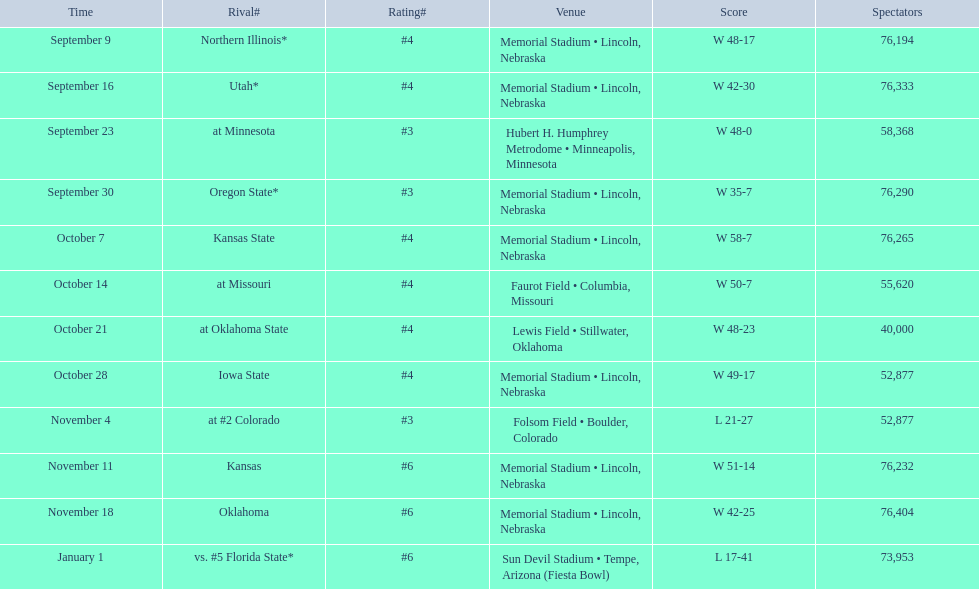Who were all of their opponents? Northern Illinois*, Utah*, at Minnesota, Oregon State*, Kansas State, at Missouri, at Oklahoma State, Iowa State, at #2 Colorado, Kansas, Oklahoma, vs. #5 Florida State*. And what was the attendance of these games? 76,194, 76,333, 58,368, 76,290, 76,265, 55,620, 40,000, 52,877, 52,877, 76,232, 76,404, 73,953. Of those numbers, which is associated with the oregon state game? 76,290. 